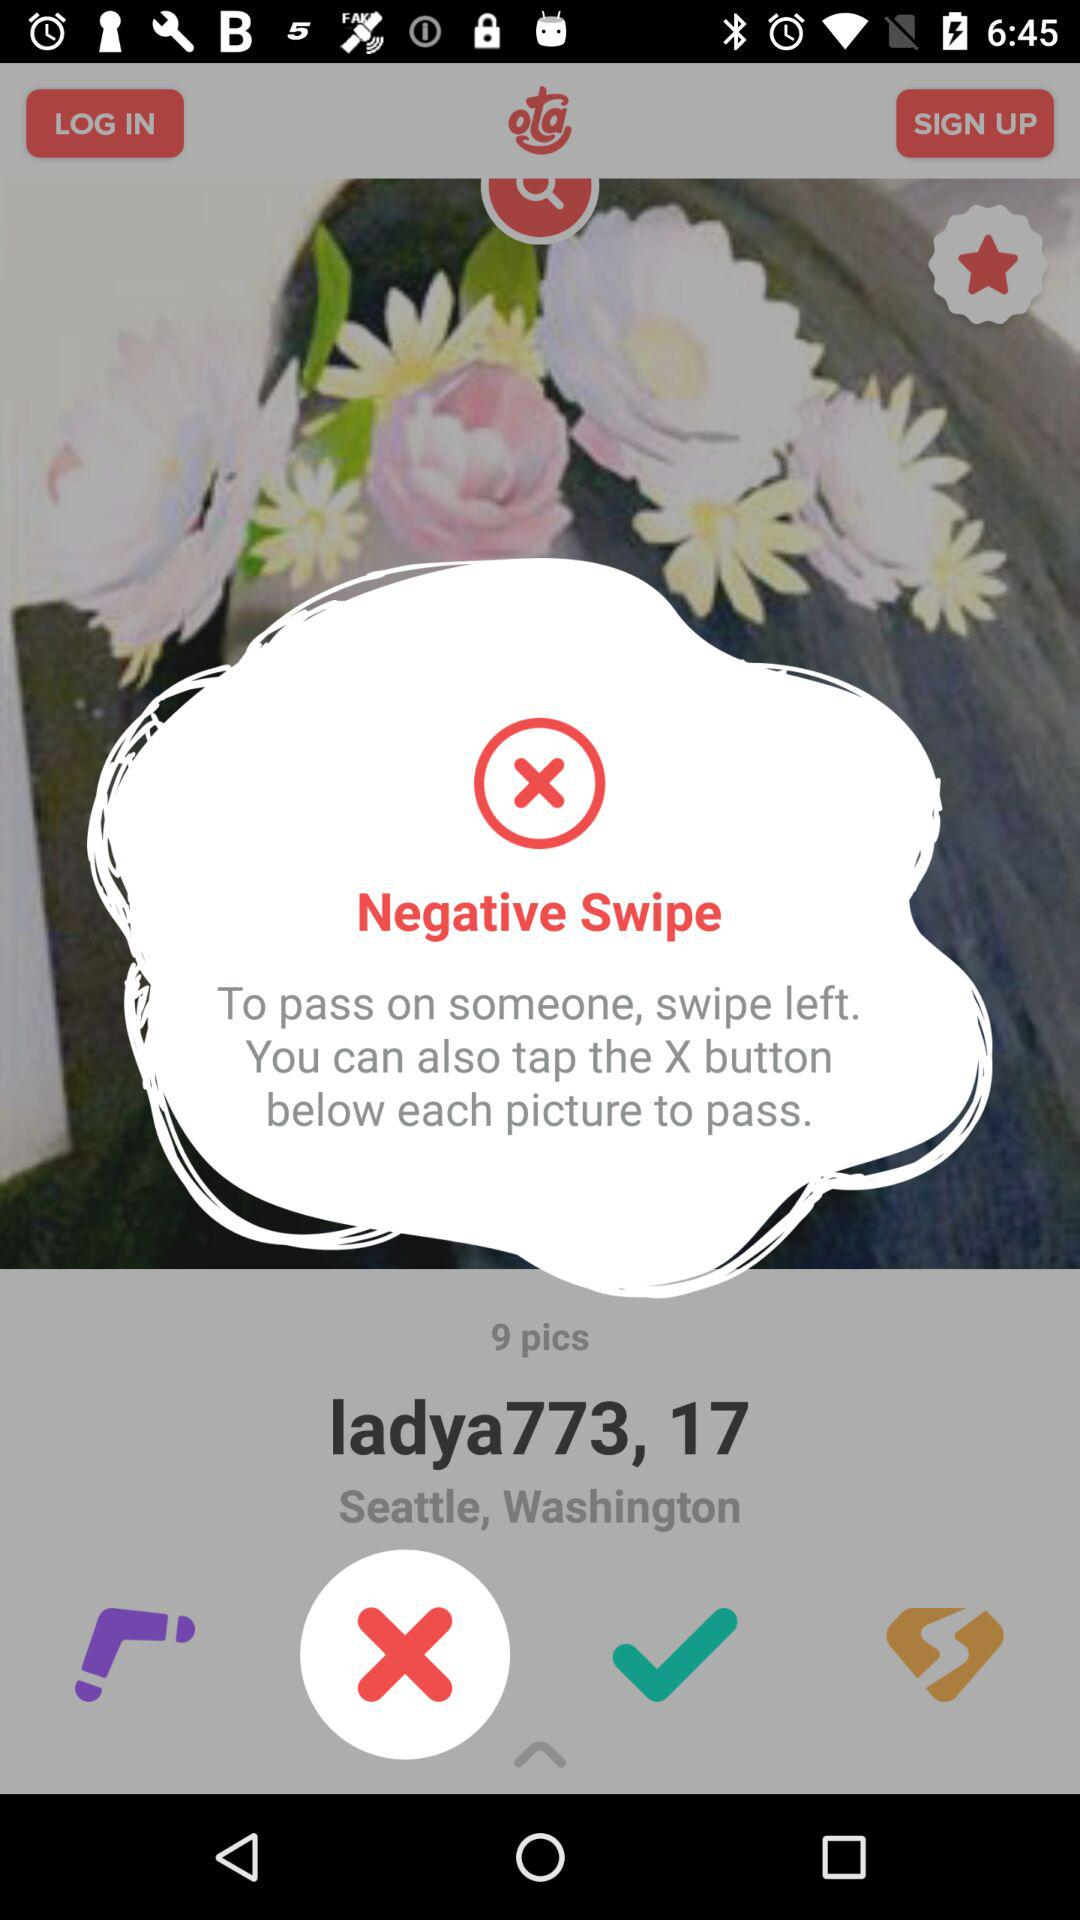What is the location of the user? The location of the user is Seattle, Washington. 